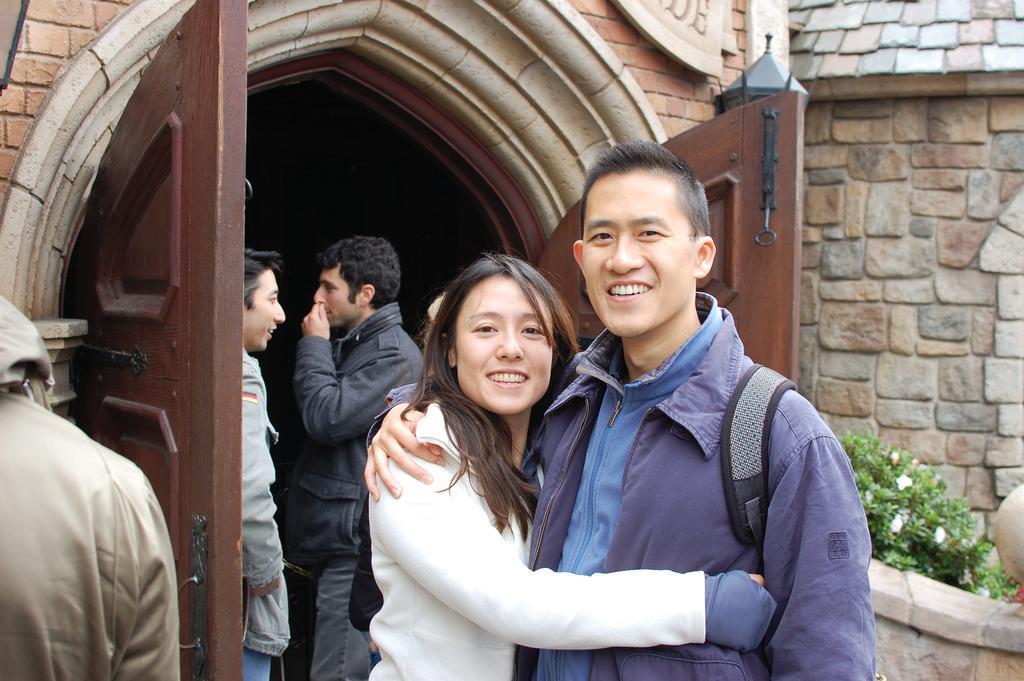In one or two sentences, can you explain what this image depicts? In this image there are some persons standing in the middle of this image and there is a wall in the background. There is a plant in the bottom right corner of this image. There is a door in the middle of this image. 